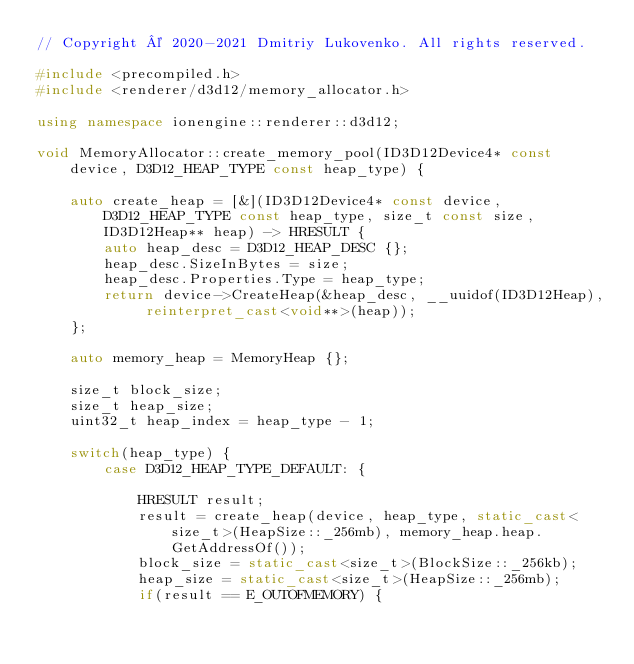<code> <loc_0><loc_0><loc_500><loc_500><_C++_>// Copyright © 2020-2021 Dmitriy Lukovenko. All rights reserved.

#include <precompiled.h>
#include <renderer/d3d12/memory_allocator.h>

using namespace ionengine::renderer::d3d12;

void MemoryAllocator::create_memory_pool(ID3D12Device4* const device, D3D12_HEAP_TYPE const heap_type) {

    auto create_heap = [&](ID3D12Device4* const device, D3D12_HEAP_TYPE const heap_type, size_t const size, ID3D12Heap** heap) -> HRESULT {
        auto heap_desc = D3D12_HEAP_DESC {};
        heap_desc.SizeInBytes = size;
        heap_desc.Properties.Type = heap_type;
        return device->CreateHeap(&heap_desc, __uuidof(ID3D12Heap), reinterpret_cast<void**>(heap));
    };

    auto memory_heap = MemoryHeap {};

    size_t block_size;
    size_t heap_size;
    uint32_t heap_index = heap_type - 1;

    switch(heap_type) {
        case D3D12_HEAP_TYPE_DEFAULT: {

            HRESULT result;
            result = create_heap(device, heap_type, static_cast<size_t>(HeapSize::_256mb), memory_heap.heap.GetAddressOf());
            block_size = static_cast<size_t>(BlockSize::_256kb);
            heap_size = static_cast<size_t>(HeapSize::_256mb);
            if(result == E_OUTOFMEMORY) {</code> 